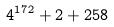Convert formula to latex. <formula><loc_0><loc_0><loc_500><loc_500>4 ^ { 1 7 2 } + 2 + 2 5 8</formula> 